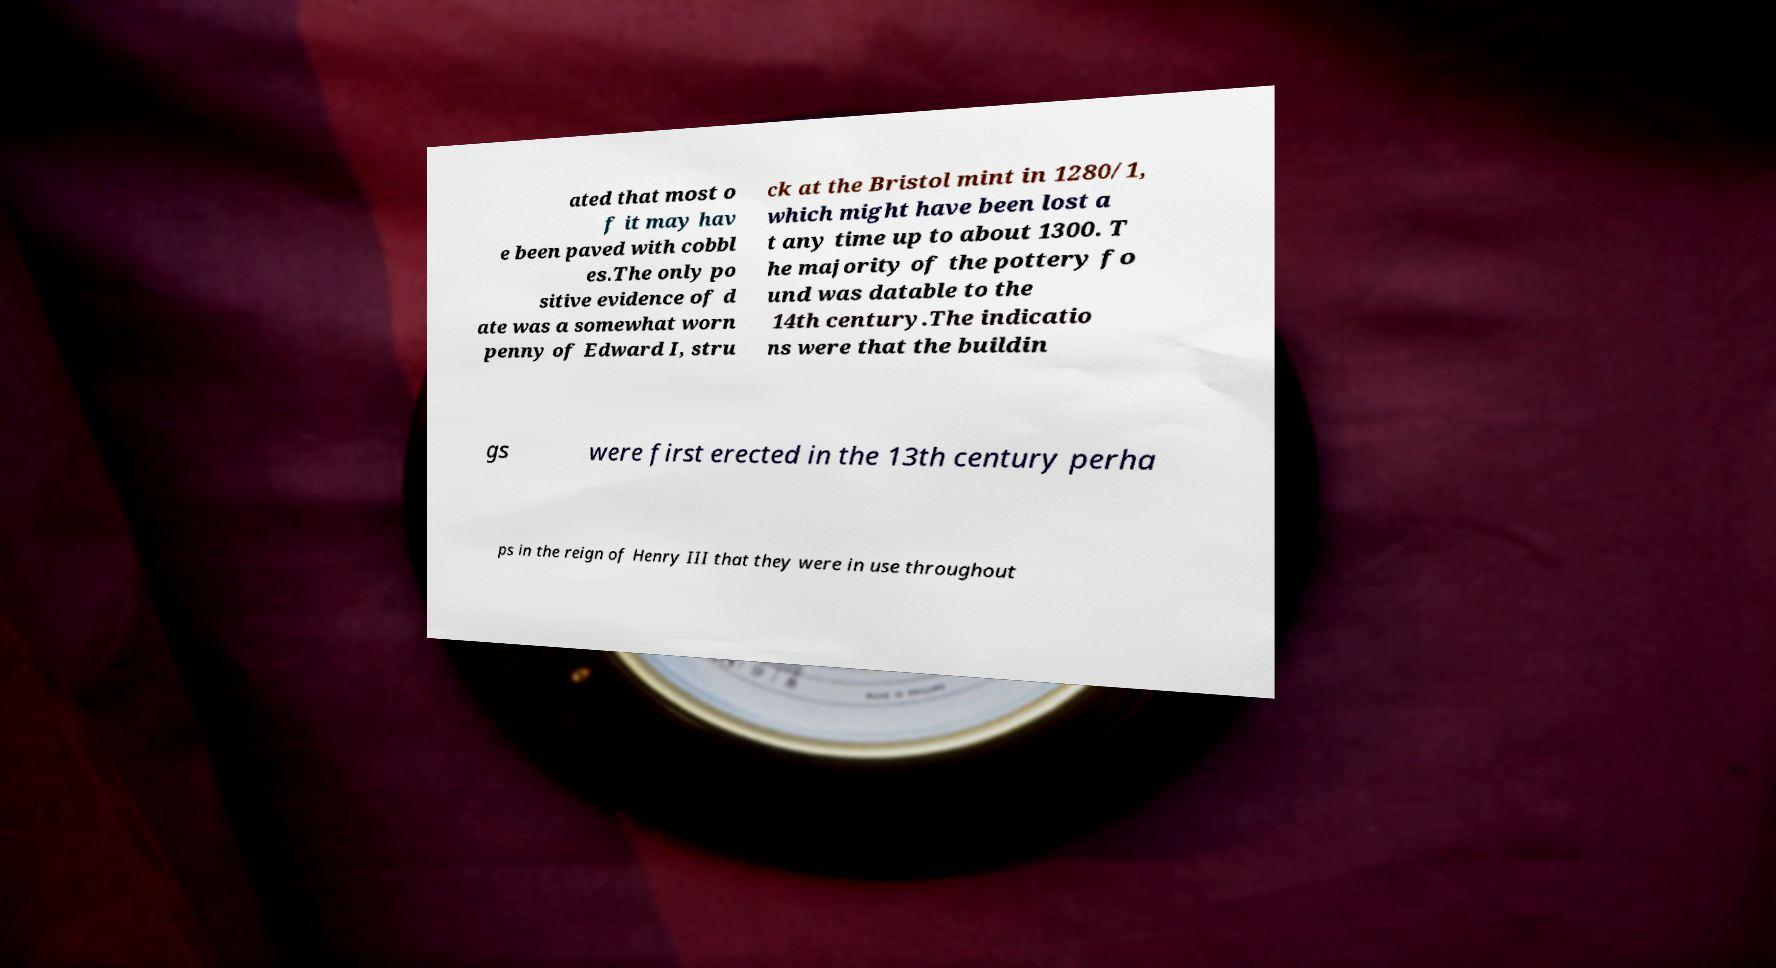For documentation purposes, I need the text within this image transcribed. Could you provide that? ated that most o f it may hav e been paved with cobbl es.The only po sitive evidence of d ate was a somewhat worn penny of Edward I, stru ck at the Bristol mint in 1280/1, which might have been lost a t any time up to about 1300. T he majority of the pottery fo und was datable to the 14th century.The indicatio ns were that the buildin gs were first erected in the 13th century perha ps in the reign of Henry III that they were in use throughout 